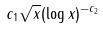<formula> <loc_0><loc_0><loc_500><loc_500>c _ { 1 } \sqrt { x } ( \log x ) ^ { - c _ { 2 } }</formula> 